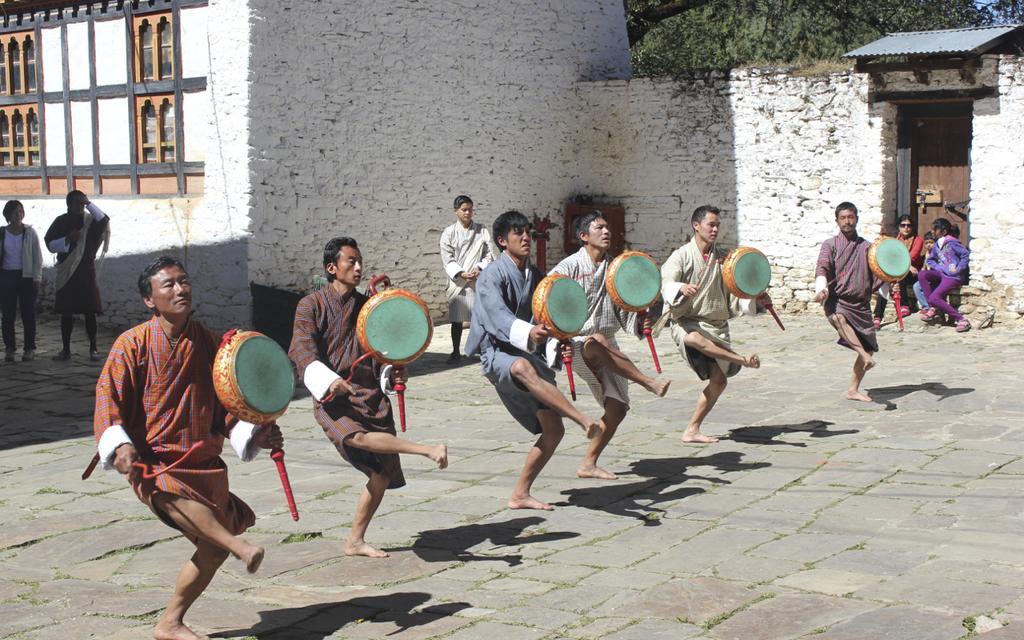Can you describe this image briefly? In this picture we can find some people are dancing holding the musical instrument. In background we can find a building, walls and door and some trees. And some people standing and watching them. 